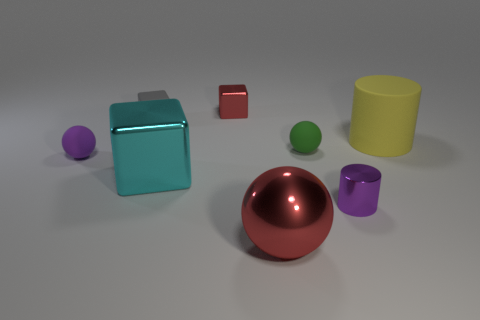What size is the other metal object that is the same shape as the big yellow object?
Give a very brief answer. Small. Do the red thing that is in front of the tiny red thing and the purple object right of the big red shiny sphere have the same material?
Offer a very short reply. Yes. Is the number of purple metal objects behind the small green rubber sphere less than the number of gray matte cylinders?
Provide a short and direct response. No. How many red shiny spheres are behind the rubber ball right of the small red block?
Keep it short and to the point. 0. What is the size of the metal object that is both in front of the big matte thing and behind the small metallic cylinder?
Ensure brevity in your answer.  Large. Is there any other thing that is the same material as the tiny purple ball?
Your answer should be compact. Yes. Does the small gray cube have the same material as the large yellow cylinder that is right of the small purple rubber sphere?
Keep it short and to the point. Yes. Is the number of large yellow rubber objects on the left side of the small green rubber ball less than the number of purple shiny cylinders that are behind the cyan shiny block?
Offer a very short reply. No. There is a purple thing that is behind the tiny cylinder; what is it made of?
Your response must be concise. Rubber. There is a ball that is both behind the shiny cylinder and in front of the green object; what color is it?
Your answer should be very brief. Purple. 